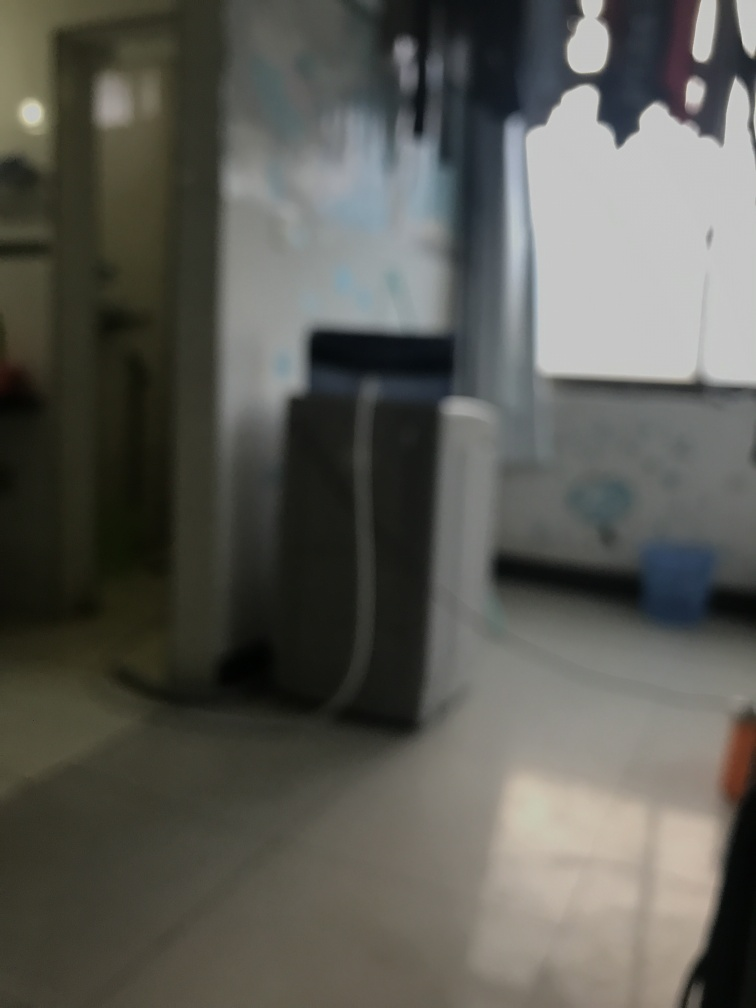Is the entrance blurry? Yes, the entrance appears to be blurry due to a shallow depth of field or possible movement during the exposure. It results in the foreground and the background of the image lacking sharpness. 